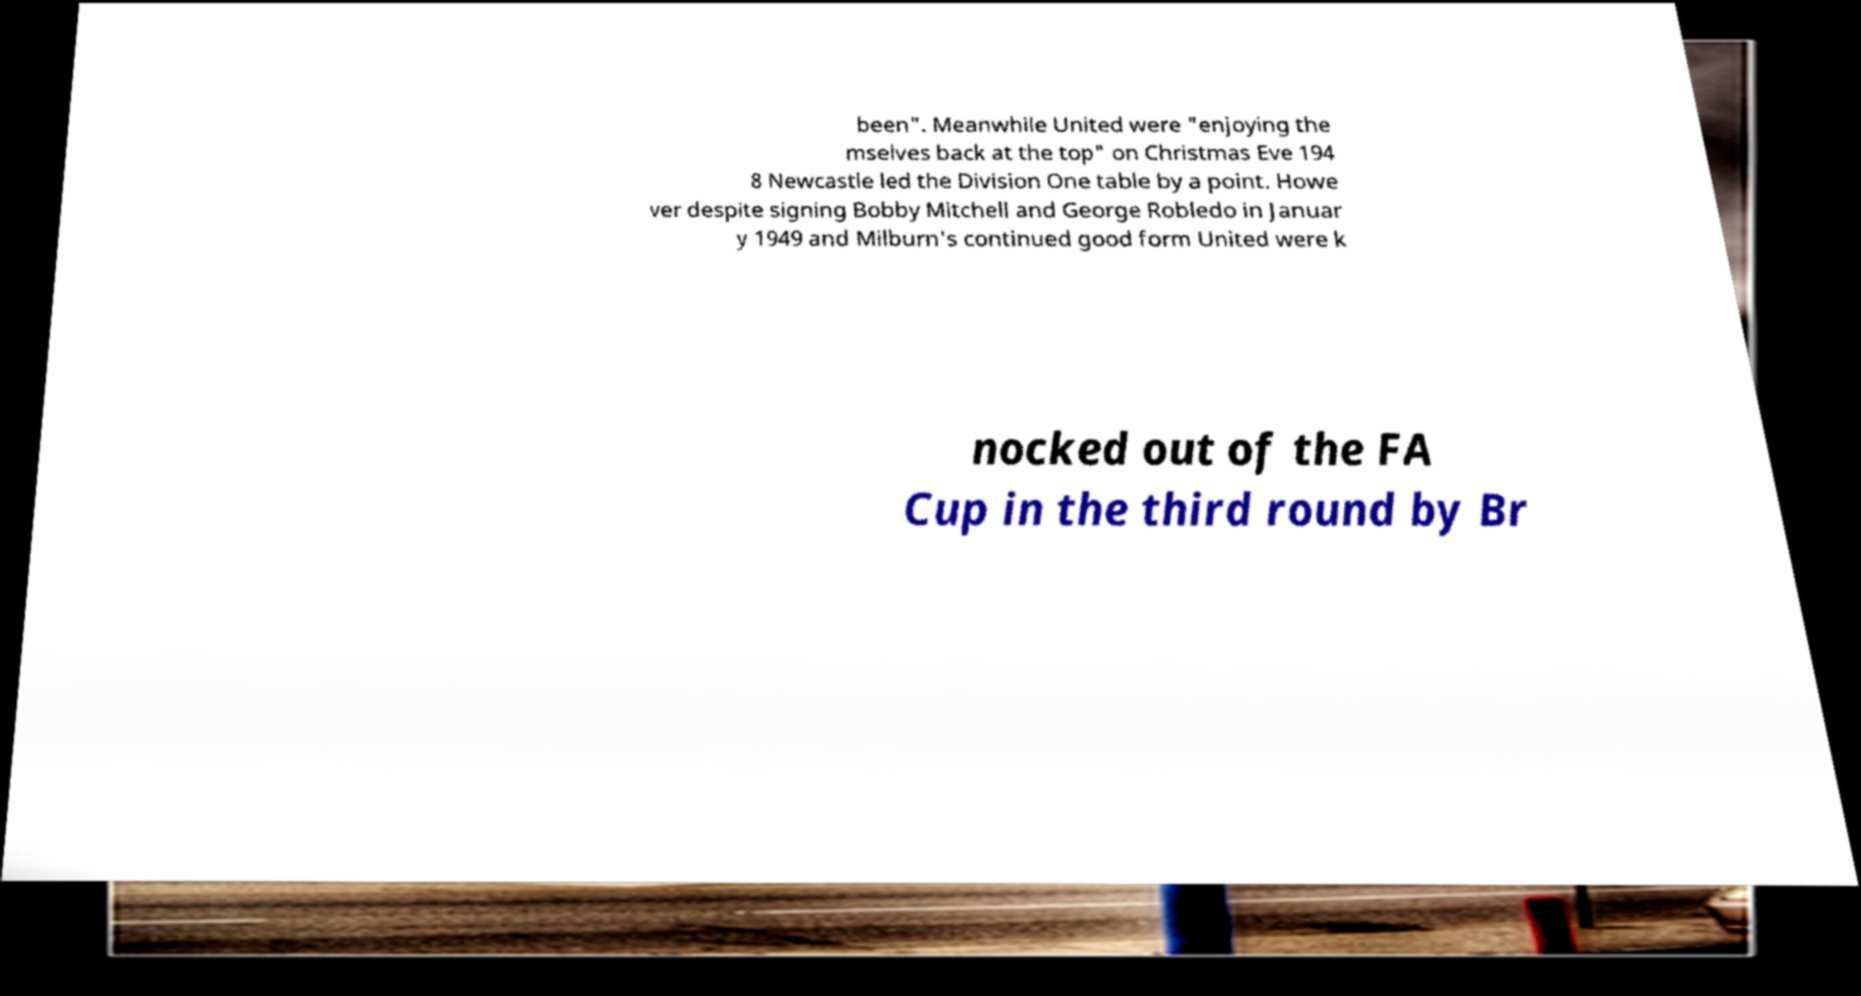For documentation purposes, I need the text within this image transcribed. Could you provide that? been". Meanwhile United were "enjoying the mselves back at the top" on Christmas Eve 194 8 Newcastle led the Division One table by a point. Howe ver despite signing Bobby Mitchell and George Robledo in Januar y 1949 and Milburn's continued good form United were k nocked out of the FA Cup in the third round by Br 